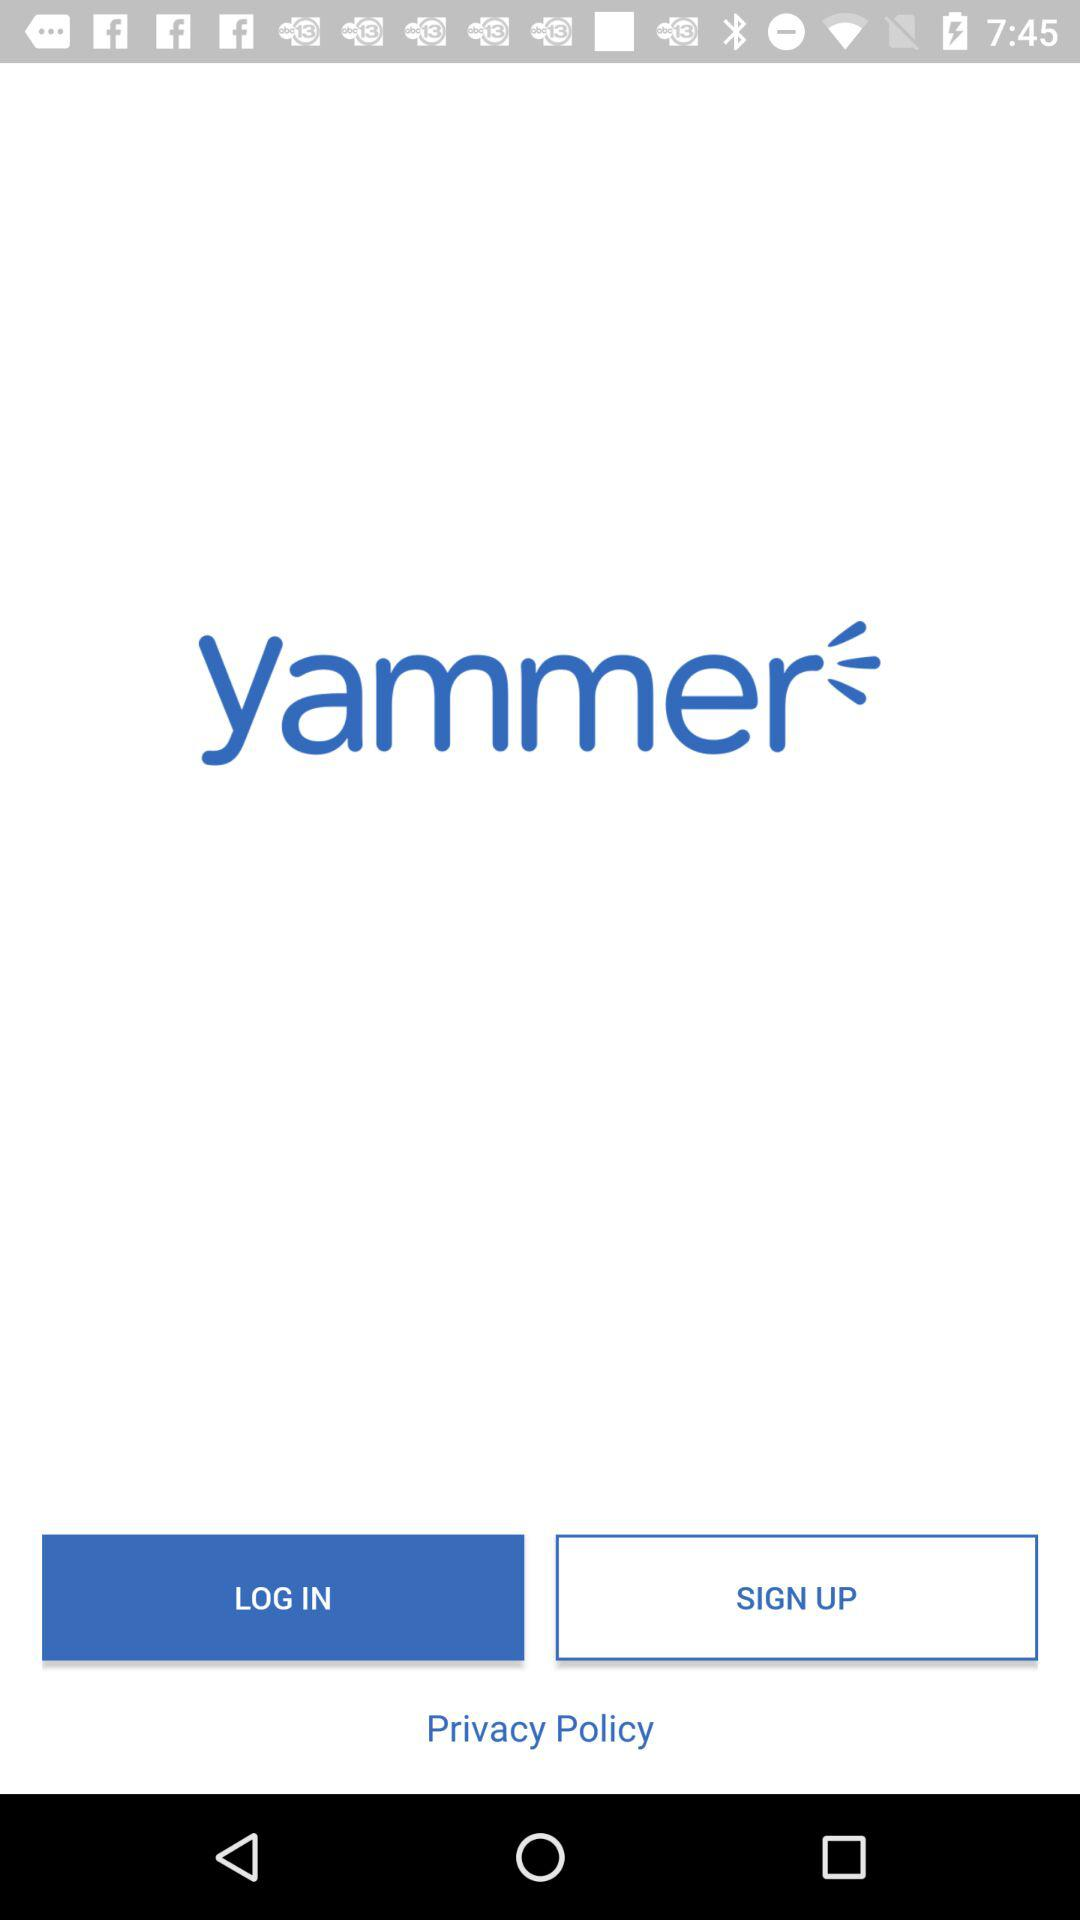What is the information provided in the privacy policy?
When the provided information is insufficient, respond with <no answer>. <no answer> 